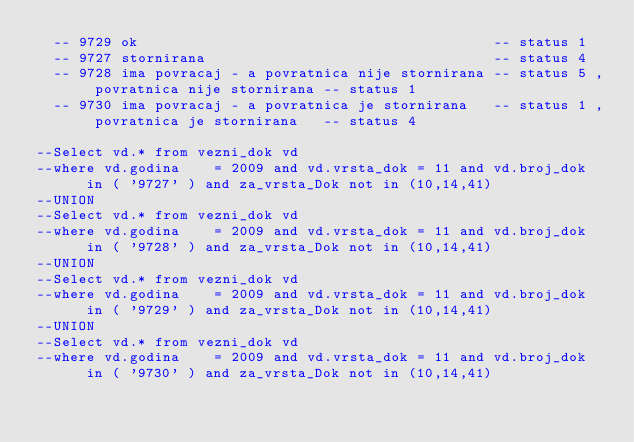<code> <loc_0><loc_0><loc_500><loc_500><_SQL_>  -- 9729 ok                                          -- status 1
  -- 9727 stornirana                                  -- status 4
  -- 9728 ima povracaj - a povratnica nije stornirana -- status 5 , povratnica nije stornirana -- status 1
  -- 9730 ima povracaj - a povratnica je stornirana   -- status 1 , povratnica je stornirana   -- status 4

--Select vd.* from vezni_dok vd
--where vd.godina    = 2009 and vd.vrsta_dok = 11 and vd.broj_dok   in ( '9727' ) and za_vrsta_Dok not in (10,14,41)
--UNION
--Select vd.* from vezni_dok vd
--where vd.godina    = 2009 and vd.vrsta_dok = 11 and vd.broj_dok   in ( '9728' ) and za_vrsta_Dok not in (10,14,41)
--UNION
--Select vd.* from vezni_dok vd
--where vd.godina    = 2009 and vd.vrsta_dok = 11 and vd.broj_dok   in ( '9729' ) and za_vrsta_Dok not in (10,14,41)
--UNION
--Select vd.* from vezni_dok vd
--where vd.godina    = 2009 and vd.vrsta_dok = 11 and vd.broj_dok   in ( '9730' ) and za_vrsta_Dok not in (10,14,41)
</code> 